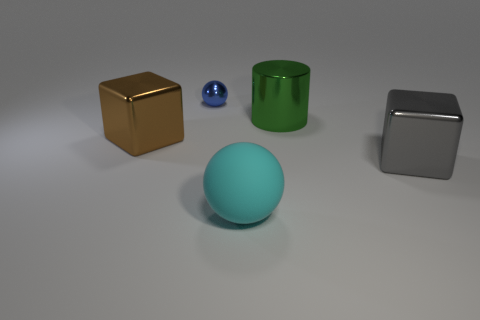Are there any other things that are the same material as the big cyan object?
Provide a short and direct response. No. Is the number of large brown metallic blocks that are behind the big cylinder the same as the number of brown blocks that are to the right of the cyan matte ball?
Ensure brevity in your answer.  Yes. What number of other things are there of the same shape as the tiny shiny object?
Make the answer very short. 1. Is the size of the shiny block on the left side of the cyan ball the same as the thing that is behind the big metal cylinder?
Make the answer very short. No. How many balls are tiny gray metallic objects or green metallic objects?
Your answer should be very brief. 0. How many matte things are either gray spheres or brown cubes?
Offer a very short reply. 0. There is another thing that is the same shape as the big cyan matte object; what size is it?
Your response must be concise. Small. Is there anything else that is the same size as the blue ball?
Keep it short and to the point. No. Is the size of the gray thing the same as the metal block to the left of the metal cylinder?
Offer a terse response. Yes. There is a shiny thing that is right of the large shiny cylinder; what is its shape?
Provide a short and direct response. Cube. 